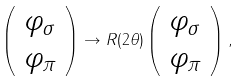Convert formula to latex. <formula><loc_0><loc_0><loc_500><loc_500>\left ( \begin{array} { l } { { \varphi _ { \sigma } } } \\ { { \varphi _ { \pi } } } \end{array} \right ) \rightarrow R ( 2 \theta ) \left ( \begin{array} { l } { { \varphi _ { \sigma } } } \\ { { \varphi _ { \pi } } } \end{array} \right ) ,</formula> 